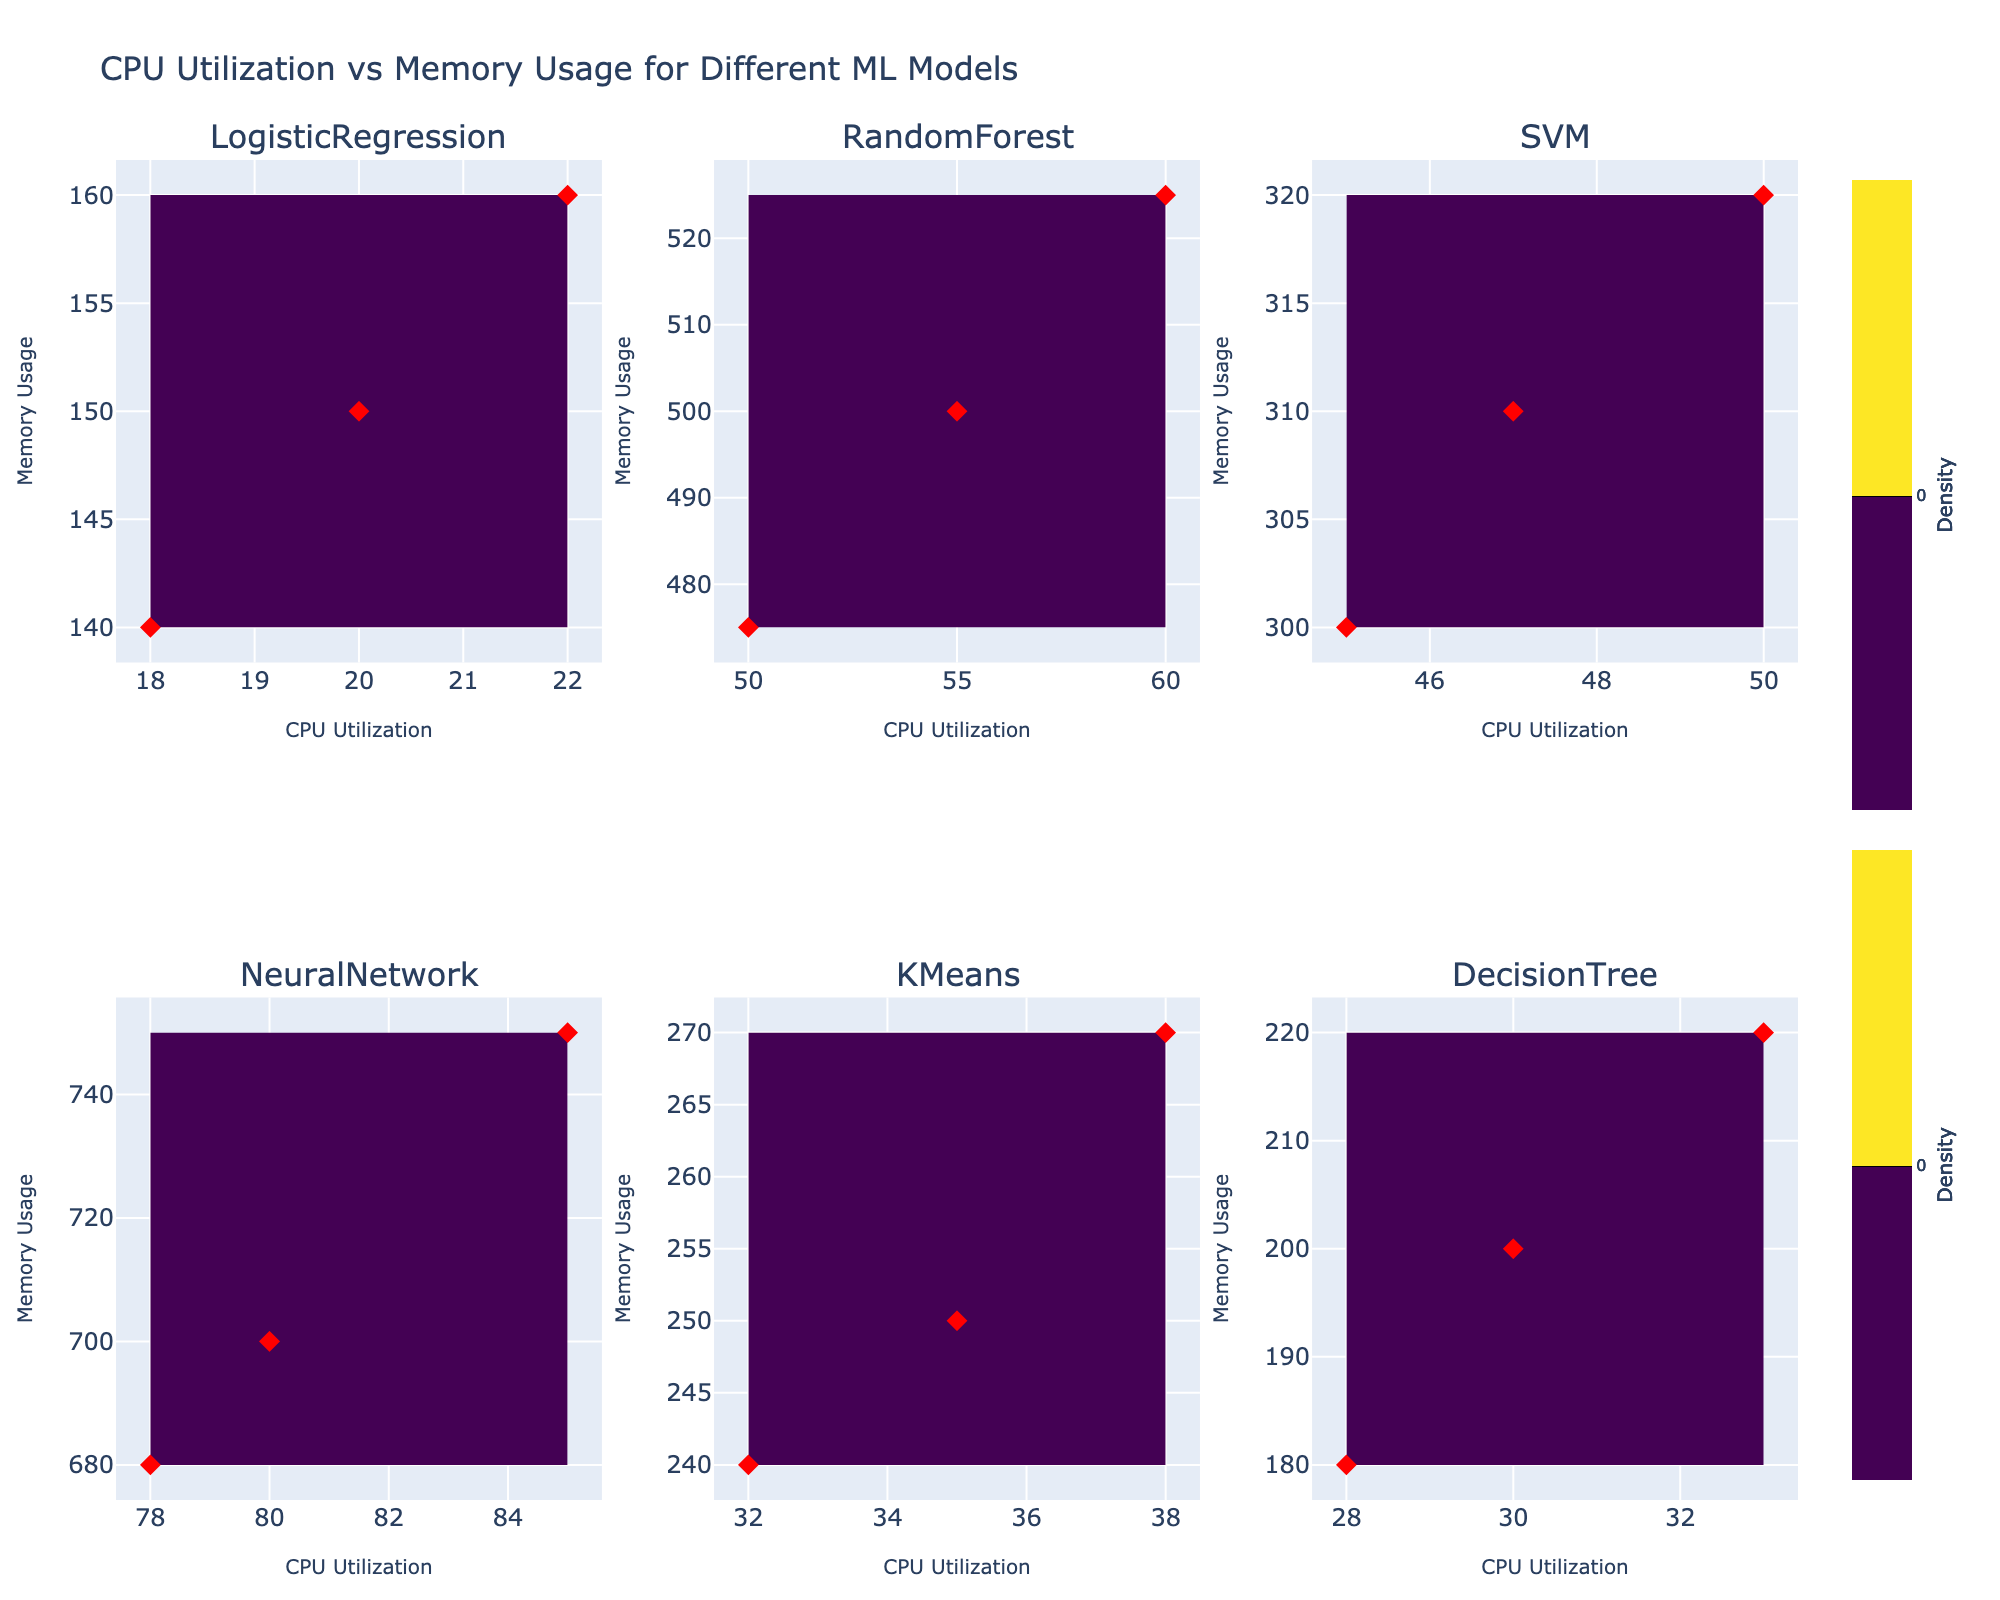Which model has the highest memory usage? By using the plots, it's visible that NeuralNetwork has the highest memory usage with readings around 700 to 750 units.
Answer: NeuralNetwork How many data points are there for the LogisticRegression model? From the subplot for LogisticRegression, you can count three red diamond markers representing three data points.
Answer: 3 Which model has the lowest CPU utilization? By glancing through the subplots, DecisionTree has the lowest CPU utilization with readings around 28, 30, and 33 units.
Answer: DecisionTree What is the average CPU utilization for the SVM model? SVM model has CPU utilization data points at 45, 50, and 47. Calculating the average: (45 + 50 + 47) / 3 = 47.33
Answer: 47.33 Between RandomForest and KMeans, which model has higher memory usage on average? RandomForest memory usage data points are 500, 525, and 475. Average: (500 + 525 + 475) / 3 = 500. KMeans memory usage data points are 250, 270, and 240. Average: (250 + 270 + 240) / 3 = 253.33. RandomForest has higher average memory usage.
Answer: RandomForest Which model shows the greatest variation in CPU utilization? To determine variation, look at the range of CPU utilization points. NeuralNetwork ranges from 78 to 85 (range 7), RandomForest ranges from 50 to 60 (range 10), LogisticRegression from 18 to 22 (range 4), SVM from 45 to 50 (range 5), KMeans from 32 to 38 (range 6), DecisionTree from 28 to 33 (range 5). RandomForest shows the greatest variation.
Answer: RandomForest Is there a correlation between CPU utilization and memory usage for the models? By inspecting the subplots, the relationship seems to vary by model. For most models, there isn't a clear linear correlation shown visually. Each model's points don't all align in a way that suggests strong positive or negative correlation consistently across subplots.
Answer: No consistent correlation Which models have CPU utilization widely spread out over the x-axis? Reviewing the x-axis spreads, RandomForest and NeuralNetwork models exhibit the most widely spread CPU utilization as their markers cover a broader range of values on the x-axis.
Answer: RandomForest and NeuralNetwork 